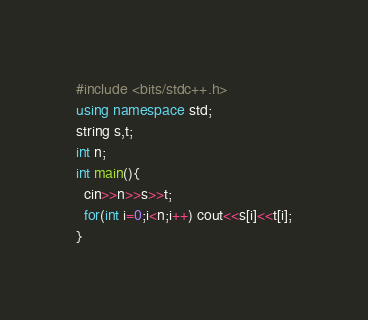<code> <loc_0><loc_0><loc_500><loc_500><_C++_>#include <bits/stdc++.h>
using namespace std;
string s,t;
int n;
int main(){
  cin>>n>>s>>t;
  for(int i=0;i<n;i++) cout<<s[i]<<t[i];
}
</code> 